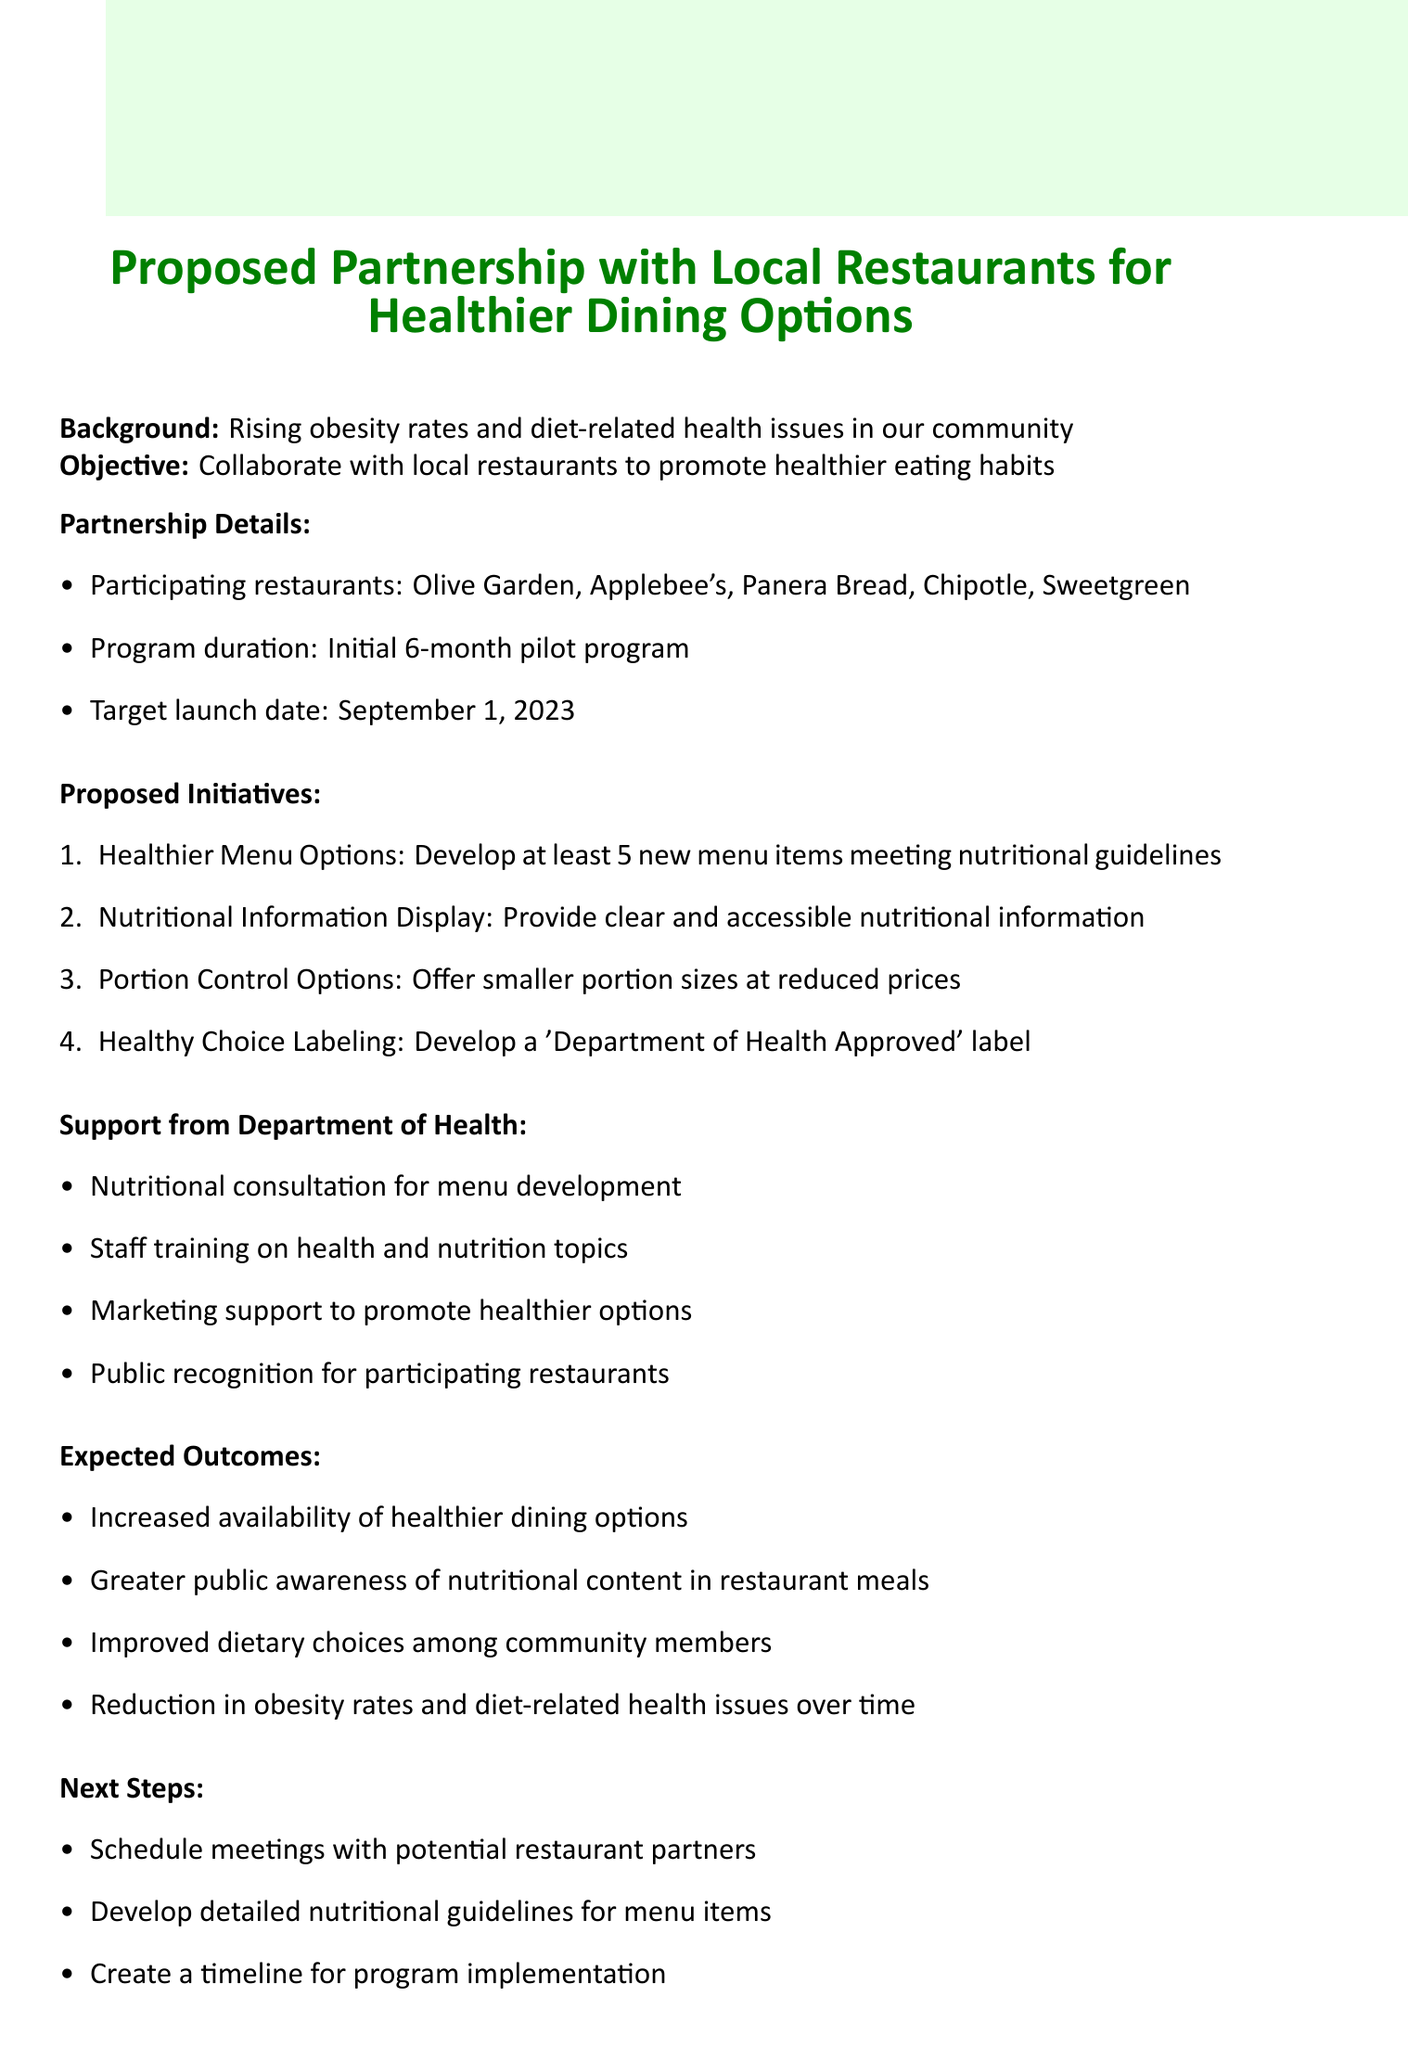What is the target launch date? The target launch date is mentioned in the partnership details section of the document.
Answer: September 1, 2023 How many participating restaurants are listed? The number of participating restaurants is found in the partnership details.
Answer: 5 What is one proposed initiative for promoting healthier eating? The document lists several proposed initiatives, highlighting efforts to improve menu options.
Answer: Healthier Menu Options What type of support will the Department of Health provide? The document outlines various forms of support offered by the Department of Health in a specified section.
Answer: Nutritional consultation for menu development What is the expected outcome related to public awareness? Expected outcomes include counteracting obesity by promoting nutritious foods and increasing awareness of meal contents.
Answer: Greater public awareness of nutritional content in restaurant meals How long is the program intended to last? The duration of the program is specified in the partnership details section.
Answer: Initial 6-month pilot program What will the 'Department of Health Approved' label indicate? The memo details initiatives that include a labeling system for healthy menu choices, focusing on qualifying items.
Answer: Qualifying menu items What is the primary objective of the partnership? The document clearly states the objective of the proposed partnership at the beginning.
Answer: Collaborate with local restaurants to promote healthier eating habits 